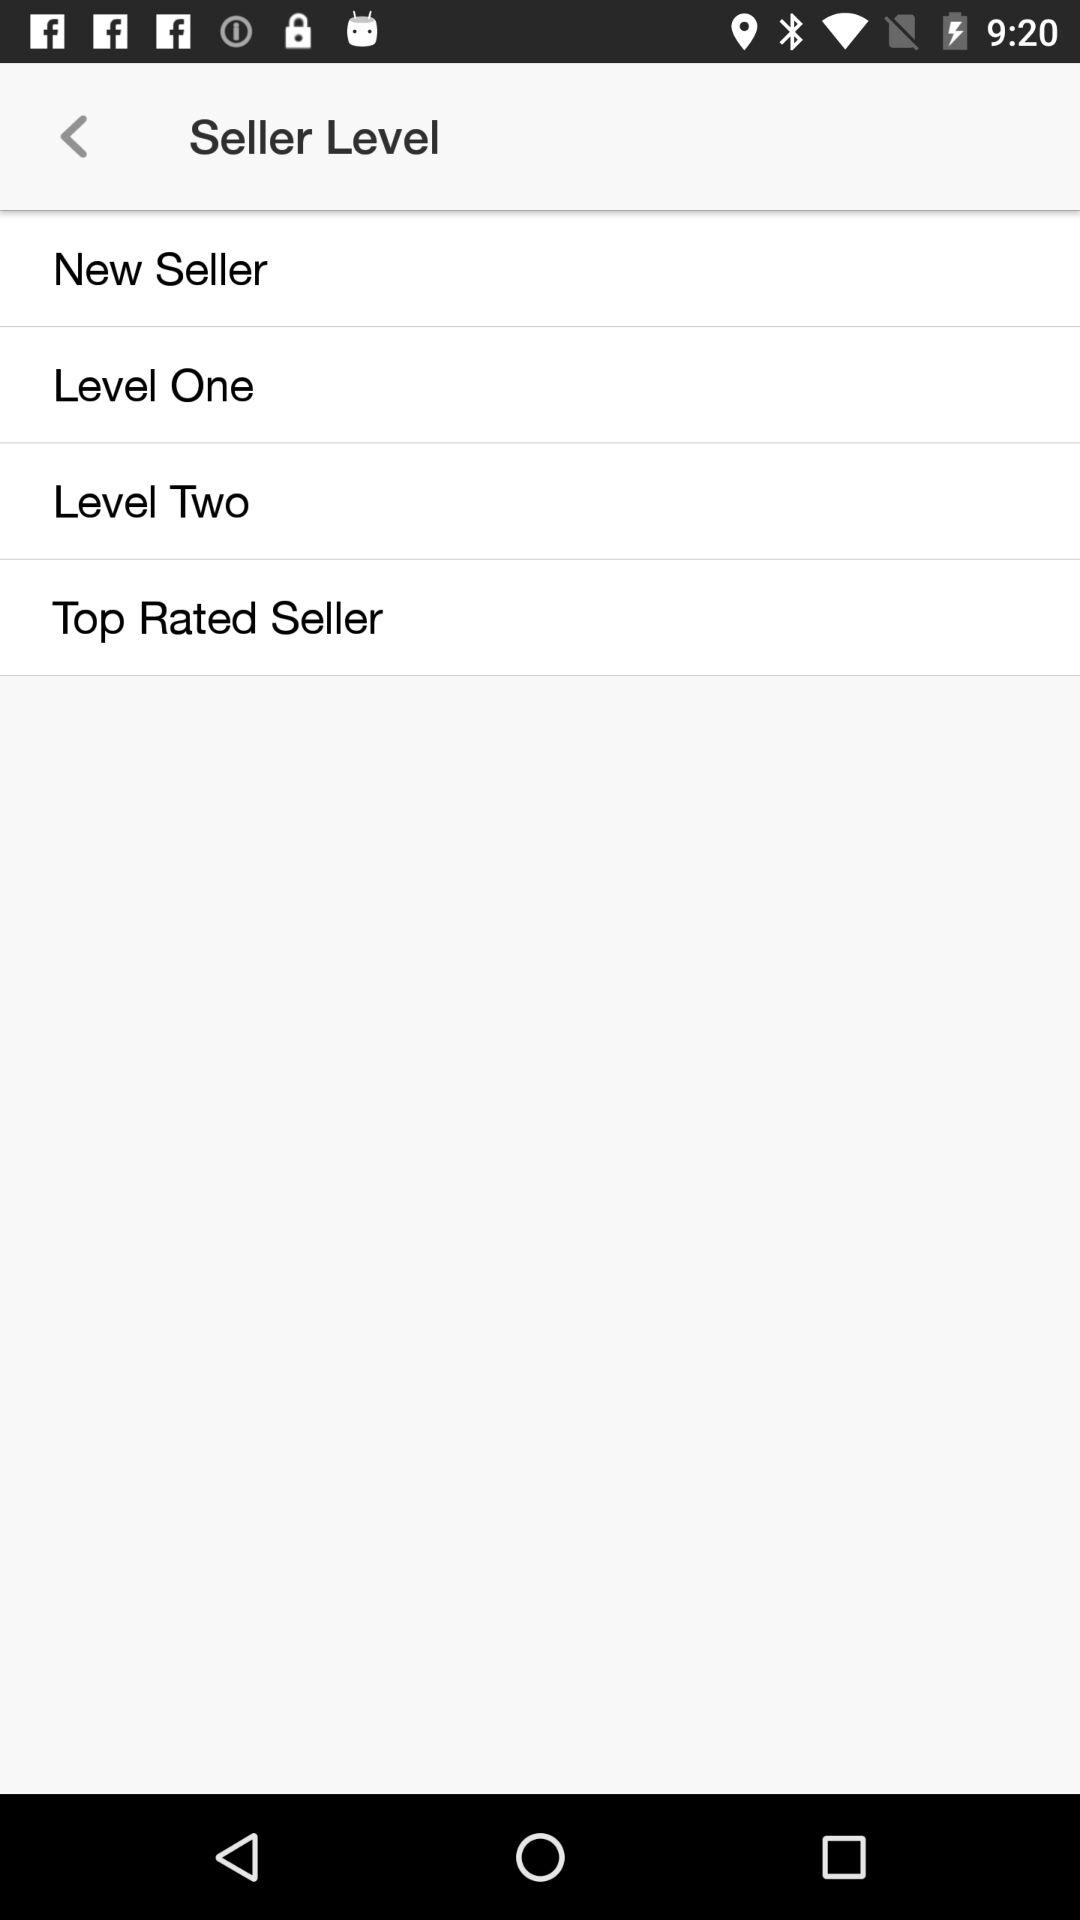How many seller levels are there?
Answer the question using a single word or phrase. 4 